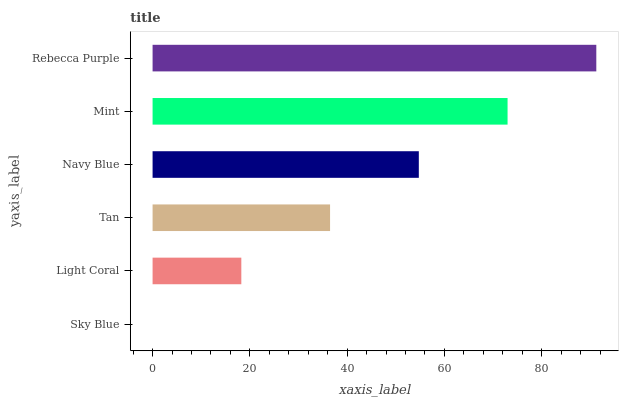Is Sky Blue the minimum?
Answer yes or no. Yes. Is Rebecca Purple the maximum?
Answer yes or no. Yes. Is Light Coral the minimum?
Answer yes or no. No. Is Light Coral the maximum?
Answer yes or no. No. Is Light Coral greater than Sky Blue?
Answer yes or no. Yes. Is Sky Blue less than Light Coral?
Answer yes or no. Yes. Is Sky Blue greater than Light Coral?
Answer yes or no. No. Is Light Coral less than Sky Blue?
Answer yes or no. No. Is Navy Blue the high median?
Answer yes or no. Yes. Is Tan the low median?
Answer yes or no. Yes. Is Rebecca Purple the high median?
Answer yes or no. No. Is Navy Blue the low median?
Answer yes or no. No. 